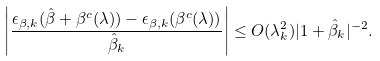Convert formula to latex. <formula><loc_0><loc_0><loc_500><loc_500>\left | \frac { \epsilon _ { \beta , k } ( \hat { \beta } + \beta ^ { c } ( \lambda ) ) - \epsilon _ { \beta , k } ( \beta ^ { c } ( \lambda ) ) } { \hat { \beta } _ { k } } \right | \leq O ( \lambda ^ { 2 } _ { k } ) | 1 + \hat { \beta } _ { k } | ^ { - 2 } .</formula> 